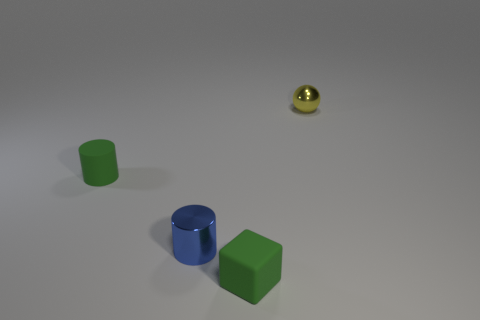There is a green rubber thing right of the green rubber cylinder; is it the same size as the tiny yellow metallic sphere? While it appears that both the green object, which is a cube, and the yellow sphere might be qualified as small objects within the image, the green cube is, in fact, larger than the yellow sphere when considering their dimensions in a three-dimensional space. The cube's edges are longer, making its overall volume greater than that of the tiny yellow metallic sphere. 